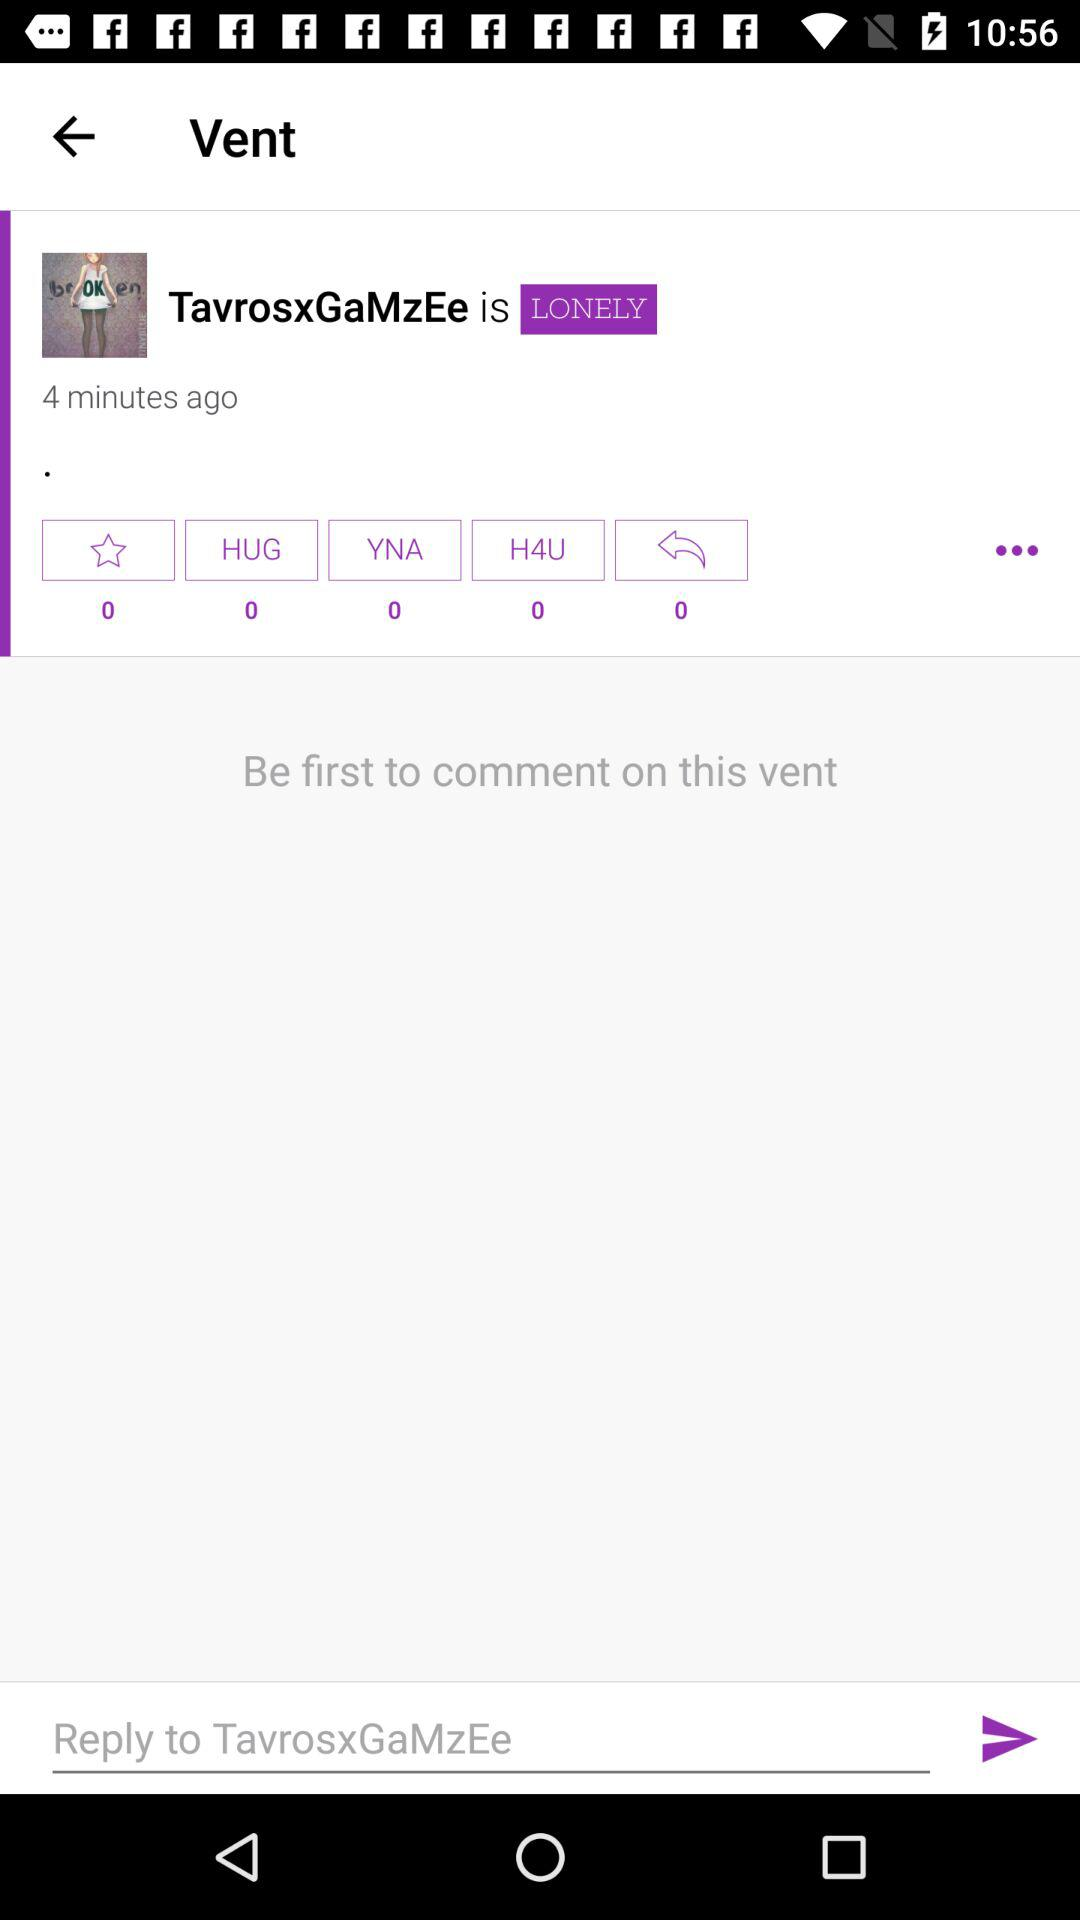How many hugs are there? There are 0 hugs. 